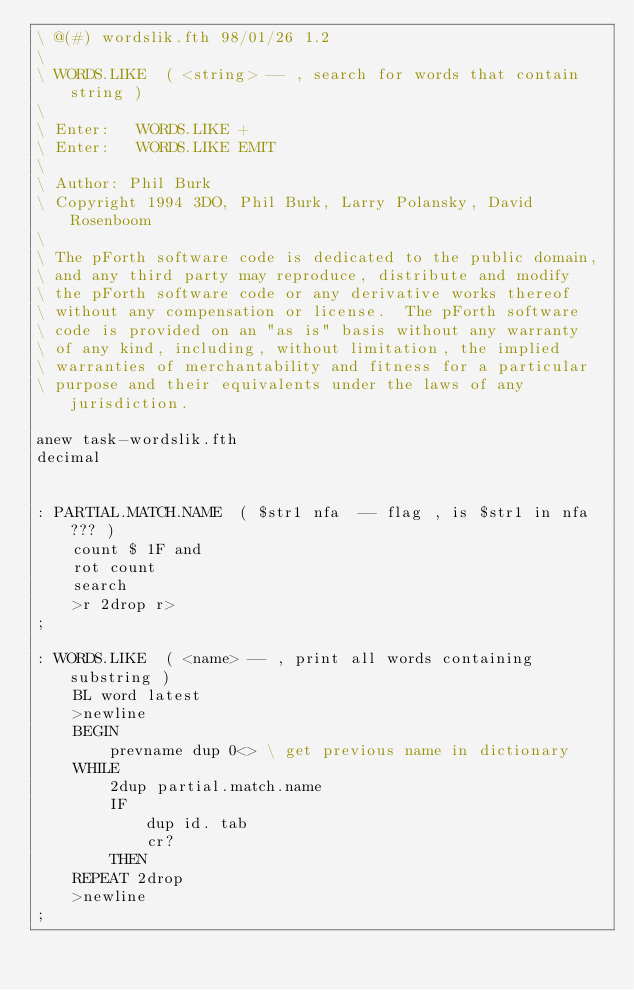<code> <loc_0><loc_0><loc_500><loc_500><_Forth_>\ @(#) wordslik.fth 98/01/26 1.2
\
\ WORDS.LIKE  ( <string> -- , search for words that contain string )
\
\ Enter:   WORDS.LIKE +
\ Enter:   WORDS.LIKE EMIT
\
\ Author: Phil Burk
\ Copyright 1994 3DO, Phil Burk, Larry Polansky, David Rosenboom
\
\ The pForth software code is dedicated to the public domain,
\ and any third party may reproduce, distribute and modify
\ the pForth software code or any derivative works thereof
\ without any compensation or license.  The pForth software
\ code is provided on an "as is" basis without any warranty
\ of any kind, including, without limitation, the implied
\ warranties of merchantability and fitness for a particular
\ purpose and their equivalents under the laws of any jurisdiction.

anew task-wordslik.fth
decimal


: PARTIAL.MATCH.NAME  ( $str1 nfa  -- flag , is $str1 in nfa ??? )
    count $ 1F and
    rot count
    search
    >r 2drop r>
;

: WORDS.LIKE  ( <name> -- , print all words containing substring )
    BL word latest
    >newline
    BEGIN
        prevname dup 0<> \ get previous name in dictionary
    WHILE
        2dup partial.match.name
        IF
            dup id. tab
            cr?
        THEN
    REPEAT 2drop
    >newline
;
</code> 